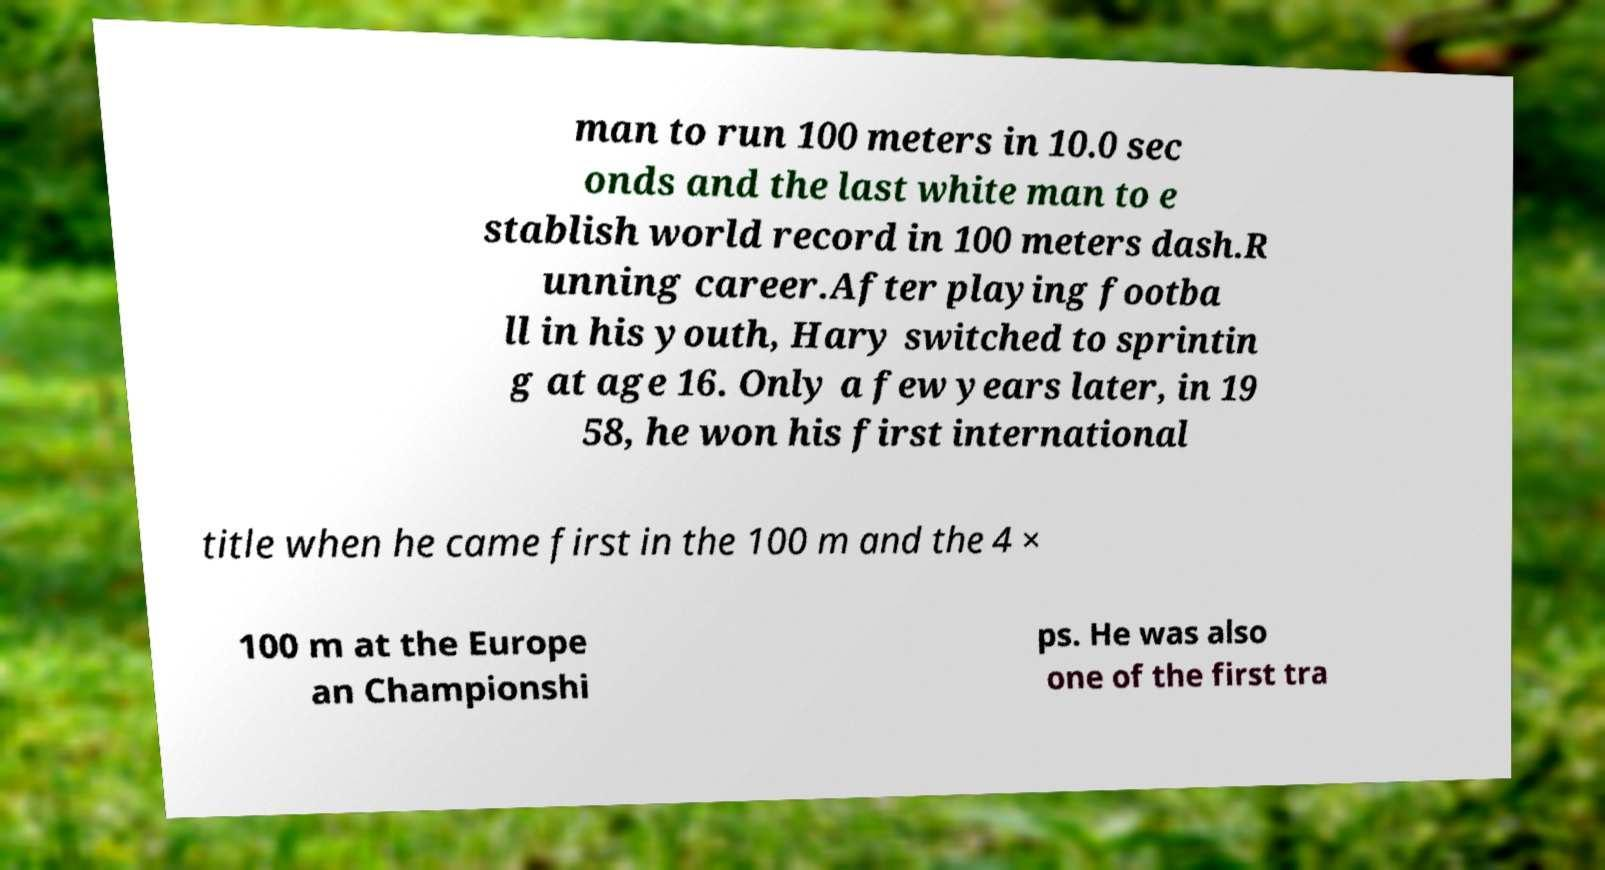Can you read and provide the text displayed in the image?This photo seems to have some interesting text. Can you extract and type it out for me? man to run 100 meters in 10.0 sec onds and the last white man to e stablish world record in 100 meters dash.R unning career.After playing footba ll in his youth, Hary switched to sprintin g at age 16. Only a few years later, in 19 58, he won his first international title when he came first in the 100 m and the 4 × 100 m at the Europe an Championshi ps. He was also one of the first tra 